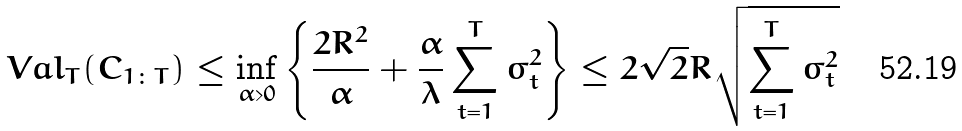Convert formula to latex. <formula><loc_0><loc_0><loc_500><loc_500>\ V a l _ { T } ( C _ { 1 \colon T } ) & \leq \inf _ { \alpha > 0 } \left \{ \frac { 2 R ^ { 2 } } { \alpha } + \frac { \alpha } { \lambda } \sum _ { t = 1 } ^ { T } \sigma _ { t } ^ { 2 } \right \} \leq 2 \sqrt { 2 } R \sqrt { \sum _ { t = 1 } ^ { T } \sigma _ { t } ^ { 2 } }</formula> 